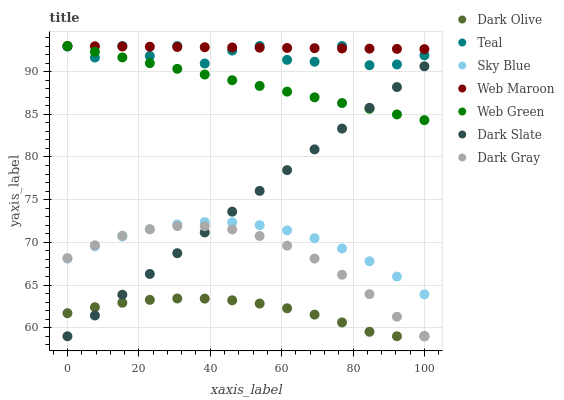Does Dark Olive have the minimum area under the curve?
Answer yes or no. Yes. Does Web Maroon have the maximum area under the curve?
Answer yes or no. Yes. Does Web Green have the minimum area under the curve?
Answer yes or no. No. Does Web Green have the maximum area under the curve?
Answer yes or no. No. Is Dark Slate the smoothest?
Answer yes or no. Yes. Is Teal the roughest?
Answer yes or no. Yes. Is Web Maroon the smoothest?
Answer yes or no. No. Is Web Maroon the roughest?
Answer yes or no. No. Does Dark Olive have the lowest value?
Answer yes or no. Yes. Does Web Green have the lowest value?
Answer yes or no. No. Does Teal have the highest value?
Answer yes or no. Yes. Does Dark Gray have the highest value?
Answer yes or no. No. Is Dark Olive less than Web Maroon?
Answer yes or no. Yes. Is Web Green greater than Dark Gray?
Answer yes or no. Yes. Does Dark Slate intersect Dark Olive?
Answer yes or no. Yes. Is Dark Slate less than Dark Olive?
Answer yes or no. No. Is Dark Slate greater than Dark Olive?
Answer yes or no. No. Does Dark Olive intersect Web Maroon?
Answer yes or no. No. 